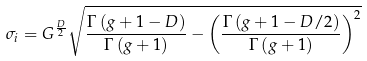Convert formula to latex. <formula><loc_0><loc_0><loc_500><loc_500>\sigma _ { i } = G ^ { \frac { D } { 2 } } \sqrt { \frac { \Gamma \left ( g + 1 - D \right ) } { \Gamma \left ( g + 1 \right ) } - \left ( \frac { \Gamma \left ( g + 1 - D / 2 \right ) } { \Gamma \left ( g + 1 \right ) } \right ) ^ { 2 } }</formula> 